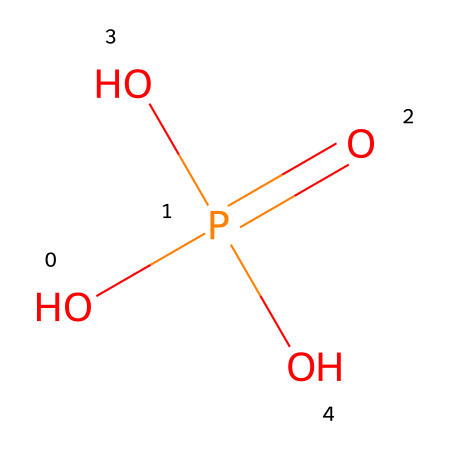What is the total number of oxygen atoms in the chemical structure? The chemical structure has three oxygen atoms represented in the "O" in the formula. Therefore, we count "O" three times in the complete SMILES representation: OP(=O)(O)O.
Answer: three What type of acid is represented by this chemical structure? The structure corresponds to phosphoric acid, which is a triprotic acid due to the three hydroxyl groups that can donate protons. This is identified from the presence of the phosphorus atom bonded to multiple oxygen atoms and hydroxyl groups.
Answer: phosphoric acid How many bonds does the phosphorus atom form in this structure? In the SMILES representation, phosphorus (P) is bonded to four different groups: one double bond with an oxygen atom (=O) and three single bonds with three hydroxyl (-OH) groups. Counting these bonds gives a total of four.
Answer: four What is the oxidation state of phosphorus in this compound? The oxidation state of phosphorus in phosphoric acid can be determined by considering the bonds formed and the electronegativities of the atoms attached. In this case, phosphorus is typically in the +5 oxidation state, as it donates five valence electrons to form bonds with the oxygen atoms.
Answer: +5 Which functional groups are present in phosphoric acid based on its structure? The structure features hydroxyl groups, which are characterized by the presence of "OH". There are three hydroxyl (-OH) functional groups in the phosphoric acid molecule, indicating its acidic properties.
Answer: hydroxyl groups What impact does this chemical structure have on the acidity of cola drinks? Phosphoric acid contributes to the acidity of cola drinks by donating protons from its hydroxyl groups, making the solution more acidic. This is evident from the structure's triprotic nature which allows it to release multiple protons in solution.
Answer: acidity 